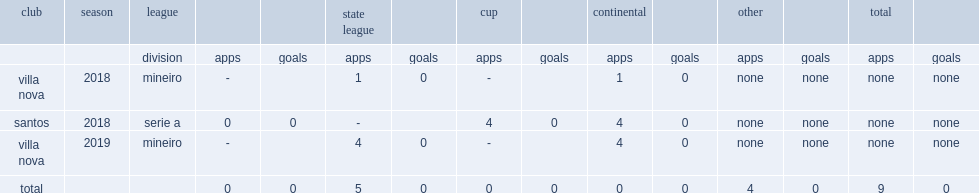When did higor felippe borges felix join in villa nova? 2018.0. 